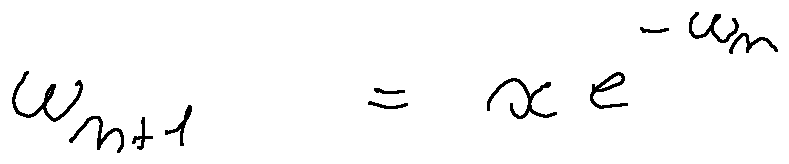<formula> <loc_0><loc_0><loc_500><loc_500>w _ { n + 1 } = x e ^ { - w _ { n } }</formula> 